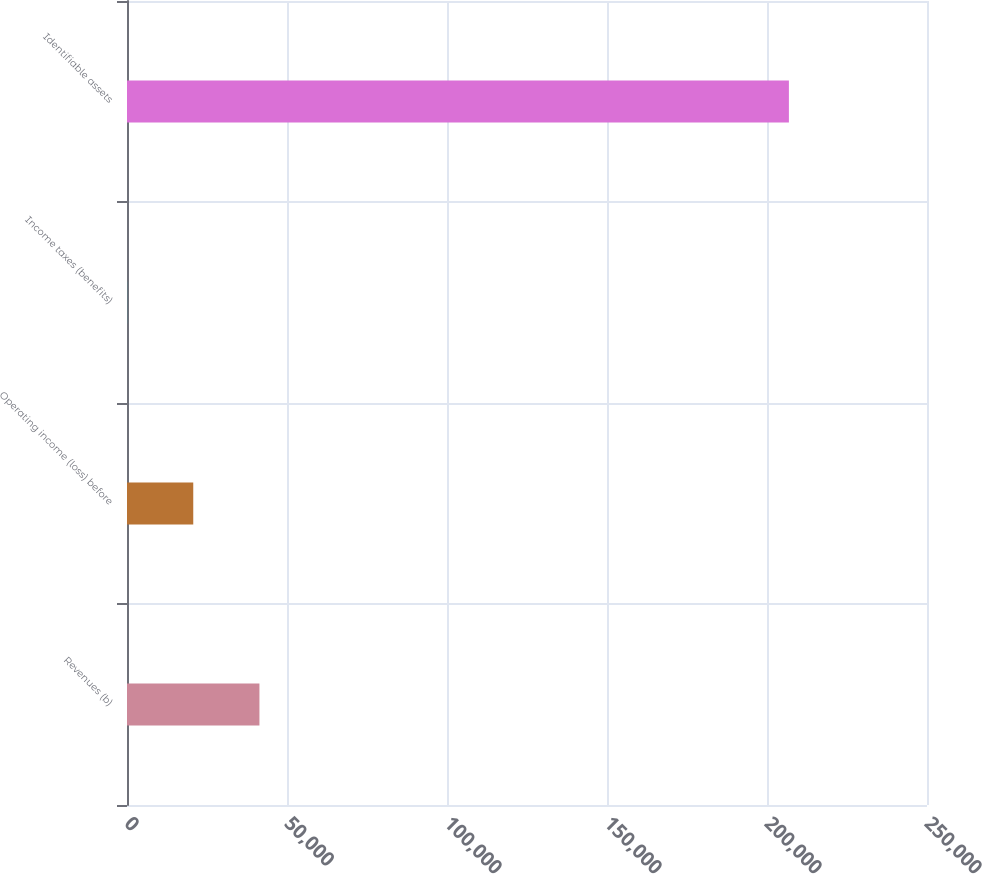<chart> <loc_0><loc_0><loc_500><loc_500><bar_chart><fcel>Revenues (b)<fcel>Operating income (loss) before<fcel>Income taxes (benefits)<fcel>Identifiable assets<nl><fcel>41387.4<fcel>20705.2<fcel>23<fcel>206845<nl></chart> 